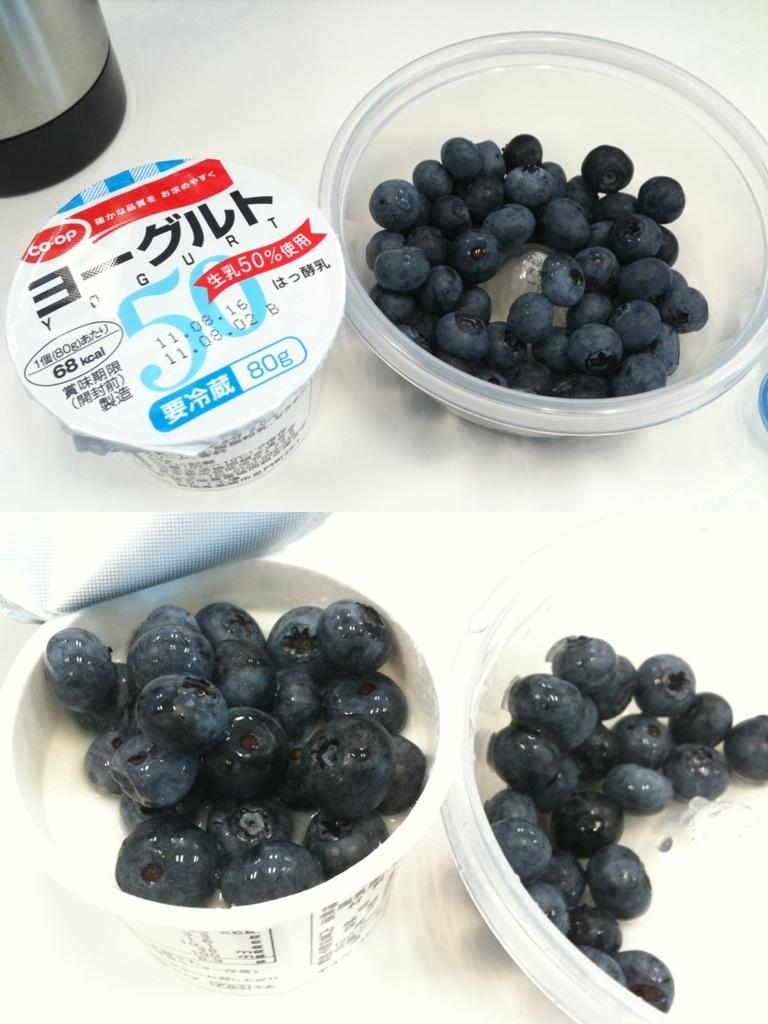What type of artwork is depicted in the image? The image is a collage. What is located at the bottom of the collage? There are blueberries and cups at the bottom of the collage. What is located at the top of the collage? There are cups and blueberries at the top of the collage. What type of fish can be seen swimming in the collage? There are no fish present in the collage; it features blueberries and cups. Can you describe the road that runs through the collage? There is no road present in the collage; it is a collage of blueberries and cups. 